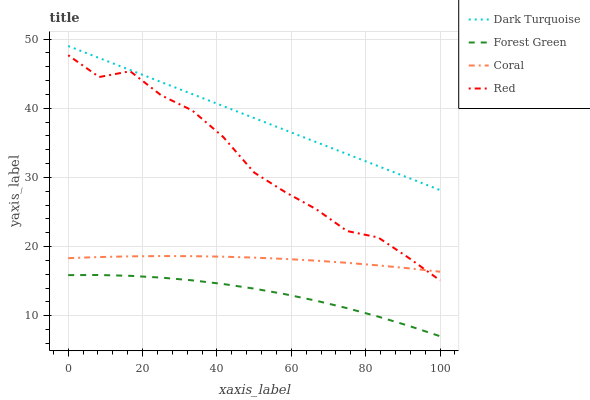Does Forest Green have the minimum area under the curve?
Answer yes or no. Yes. Does Dark Turquoise have the maximum area under the curve?
Answer yes or no. Yes. Does Coral have the minimum area under the curve?
Answer yes or no. No. Does Coral have the maximum area under the curve?
Answer yes or no. No. Is Dark Turquoise the smoothest?
Answer yes or no. Yes. Is Red the roughest?
Answer yes or no. Yes. Is Forest Green the smoothest?
Answer yes or no. No. Is Forest Green the roughest?
Answer yes or no. No. Does Forest Green have the lowest value?
Answer yes or no. Yes. Does Coral have the lowest value?
Answer yes or no. No. Does Dark Turquoise have the highest value?
Answer yes or no. Yes. Does Coral have the highest value?
Answer yes or no. No. Is Forest Green less than Red?
Answer yes or no. Yes. Is Red greater than Forest Green?
Answer yes or no. Yes. Does Red intersect Coral?
Answer yes or no. Yes. Is Red less than Coral?
Answer yes or no. No. Is Red greater than Coral?
Answer yes or no. No. Does Forest Green intersect Red?
Answer yes or no. No. 